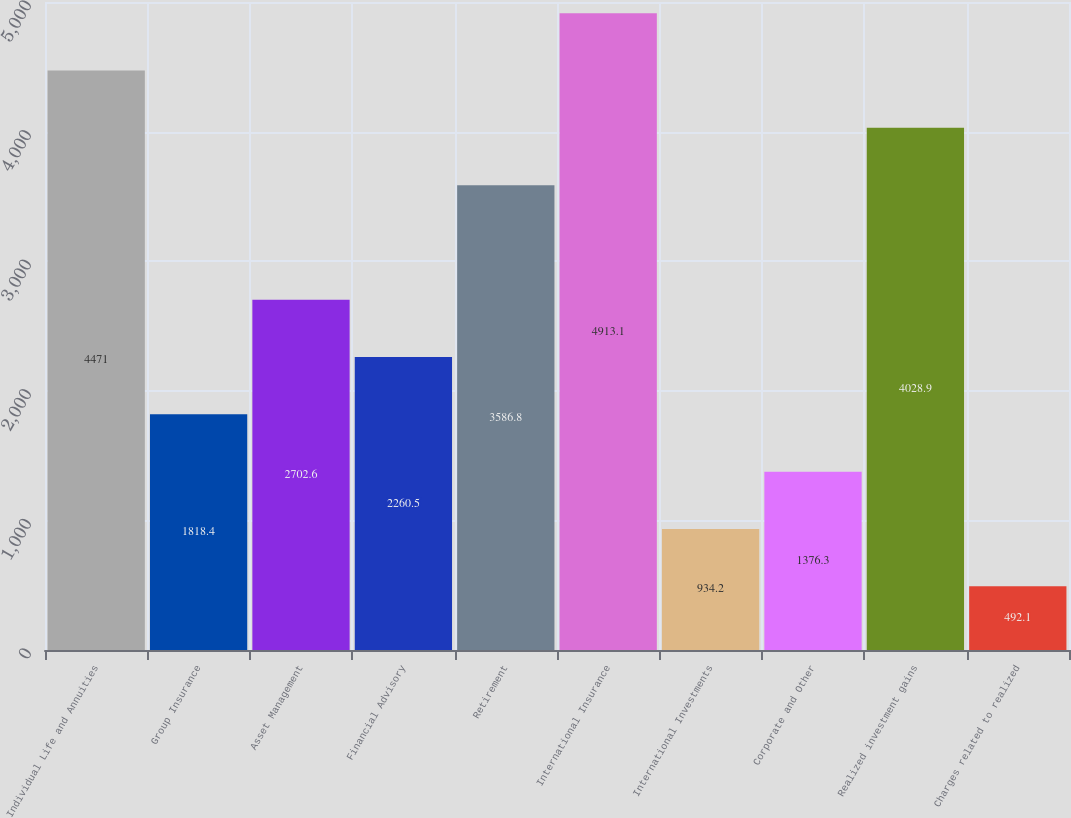<chart> <loc_0><loc_0><loc_500><loc_500><bar_chart><fcel>Individual Life and Annuities<fcel>Group Insurance<fcel>Asset Management<fcel>Financial Advisory<fcel>Retirement<fcel>International Insurance<fcel>International Investments<fcel>Corporate and Other<fcel>Realized investment gains<fcel>Charges related to realized<nl><fcel>4471<fcel>1818.4<fcel>2702.6<fcel>2260.5<fcel>3586.8<fcel>4913.1<fcel>934.2<fcel>1376.3<fcel>4028.9<fcel>492.1<nl></chart> 